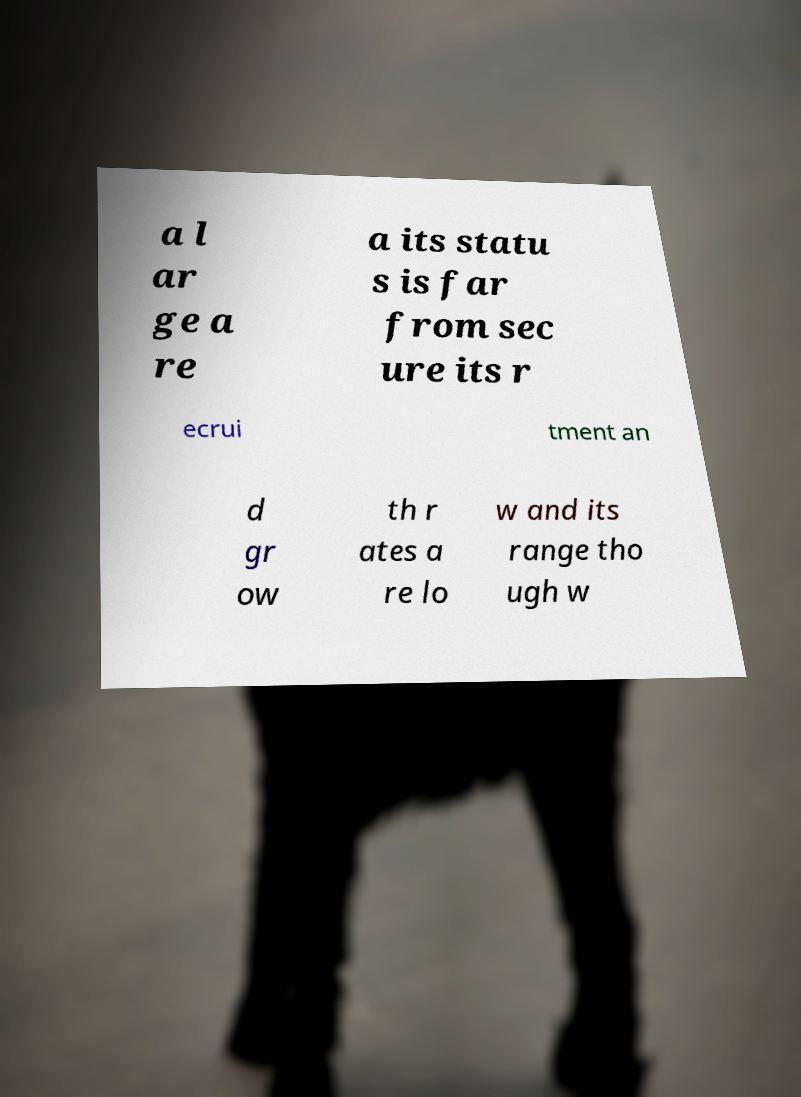What messages or text are displayed in this image? I need them in a readable, typed format. a l ar ge a re a its statu s is far from sec ure its r ecrui tment an d gr ow th r ates a re lo w and its range tho ugh w 